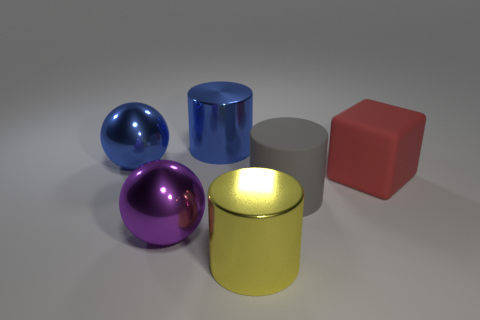What do the surfaces of these objects tell us about the environment they are in? The highly reflective surfaces suggest that these objects are in a controlled, artificially lit environment, likely indoors. The consistent and soft shadows indicate diffuse lighting, possibly from multiple light sources or ambient lights. Is there anything indicating the size of these objects? Without a familiar object to provide scale, it's challenging to determine the absolute size of these objects, though they appear to be of a size that could comfortably fit on a tabletop. 